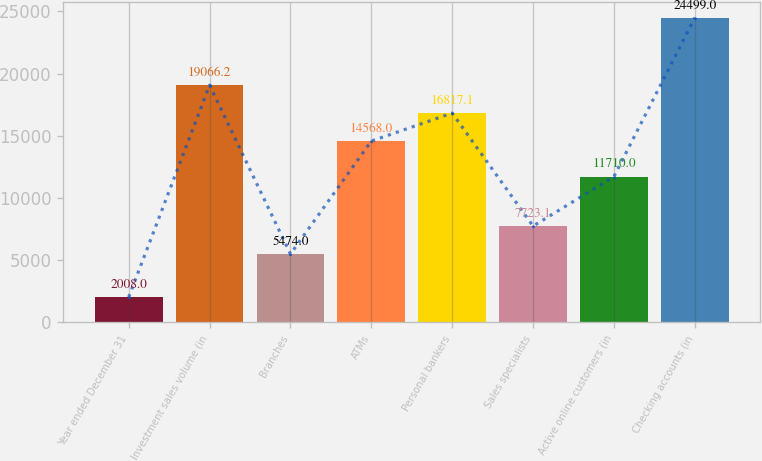Convert chart. <chart><loc_0><loc_0><loc_500><loc_500><bar_chart><fcel>Year ended December 31<fcel>Investment sales volume (in<fcel>Branches<fcel>ATMs<fcel>Personal bankers<fcel>Sales specialists<fcel>Active online customers (in<fcel>Checking accounts (in<nl><fcel>2008<fcel>19066.2<fcel>5474<fcel>14568<fcel>16817.1<fcel>7723.1<fcel>11710<fcel>24499<nl></chart> 